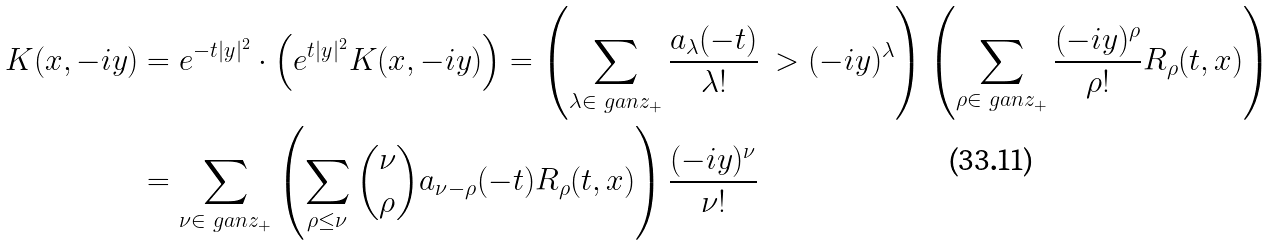Convert formula to latex. <formula><loc_0><loc_0><loc_500><loc_500>K ( x , - i y ) & = e ^ { - t | y | ^ { 2 } } \cdot \left ( e ^ { t | y | ^ { 2 } } K ( x , - i y ) \right ) = \left ( \sum _ { \lambda \in \ g a n z _ { + } } \frac { a _ { \lambda } ( - t ) } { \lambda ! } \ > ( - i y ) ^ { \lambda } \right ) \left ( \sum _ { \rho \in \ g a n z _ { + } } \frac { ( - i y ) ^ { \rho } } { \rho ! } R _ { \rho } ( t , x ) \right ) \\ & = \sum _ { \nu \in \ g a n z _ { + } } \left ( \sum _ { \rho \leq \nu } \binom { \nu } { \rho } a _ { \nu - \rho } ( - t ) R _ { \rho } ( t , x ) \right ) \frac { ( - i y ) ^ { \nu } } { \nu ! }</formula> 